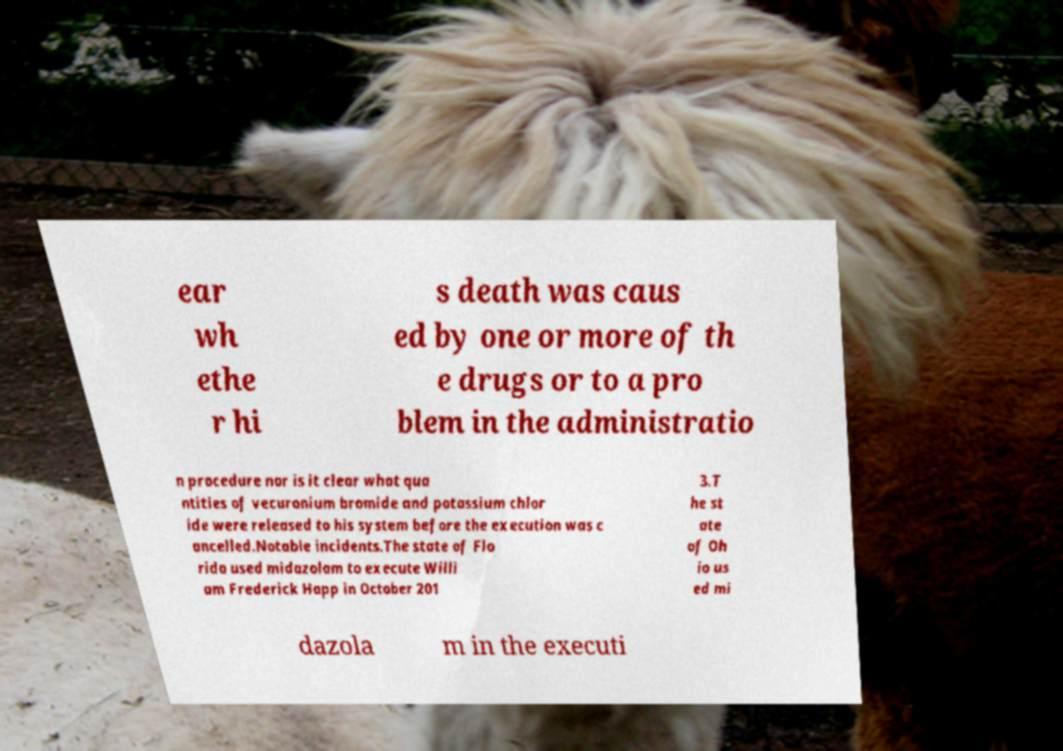Please identify and transcribe the text found in this image. ear wh ethe r hi s death was caus ed by one or more of th e drugs or to a pro blem in the administratio n procedure nor is it clear what qua ntities of vecuronium bromide and potassium chlor ide were released to his system before the execution was c ancelled.Notable incidents.The state of Flo rida used midazolam to execute Willi am Frederick Happ in October 201 3.T he st ate of Oh io us ed mi dazola m in the executi 